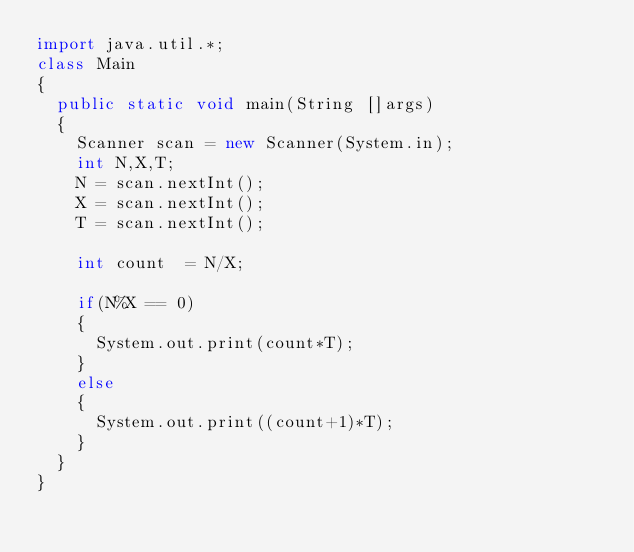<code> <loc_0><loc_0><loc_500><loc_500><_Java_>import java.util.*;
class Main
{
	public static void main(String []args)
	{
		Scanner scan = new Scanner(System.in);
		int N,X,T;
		N = scan.nextInt();
		X = scan.nextInt();
		T = scan.nextInt();
		
		int count  = N/X;
		
		if(N%X == 0)
		{
			System.out.print(count*T);
		}
		else
		{
			System.out.print((count+1)*T);
		}
	}
}</code> 